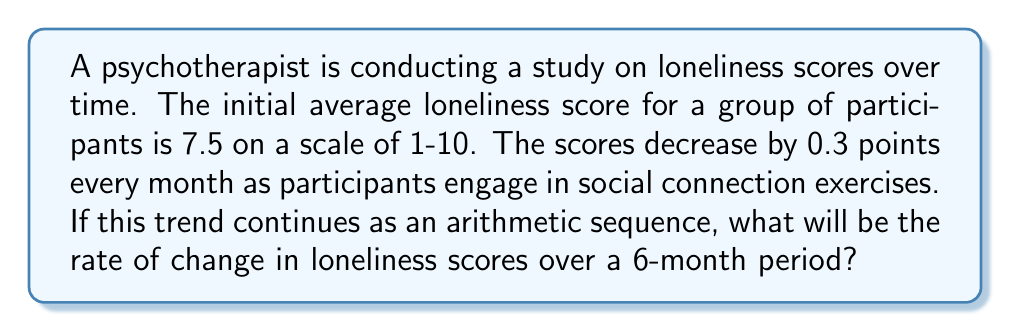Can you answer this question? To solve this problem, we need to understand the concept of arithmetic sequences and rate of change.

1. Identify the arithmetic sequence:
   - Initial term (a₁) = 7.5
   - Common difference (d) = -0.3 (scores decrease by 0.3 each month)

2. Calculate the 6th term of the sequence:
   $$a_n = a_1 + (n-1)d$$
   $$a_6 = 7.5 + (6-1)(-0.3)$$
   $$a_6 = 7.5 - 1.5 = 6$$

3. Calculate the total change over 6 months:
   Total change = Final term - Initial term
   $$\text{Total change} = 6 - 7.5 = -1.5$$

4. Calculate the rate of change:
   Rate of change = Total change / Time period
   $$\text{Rate of change} = \frac{-1.5}{6} = -0.25$$

Therefore, the rate of change in loneliness scores over a 6-month period is -0.25 points per month.
Answer: $-0.25$ points per month 